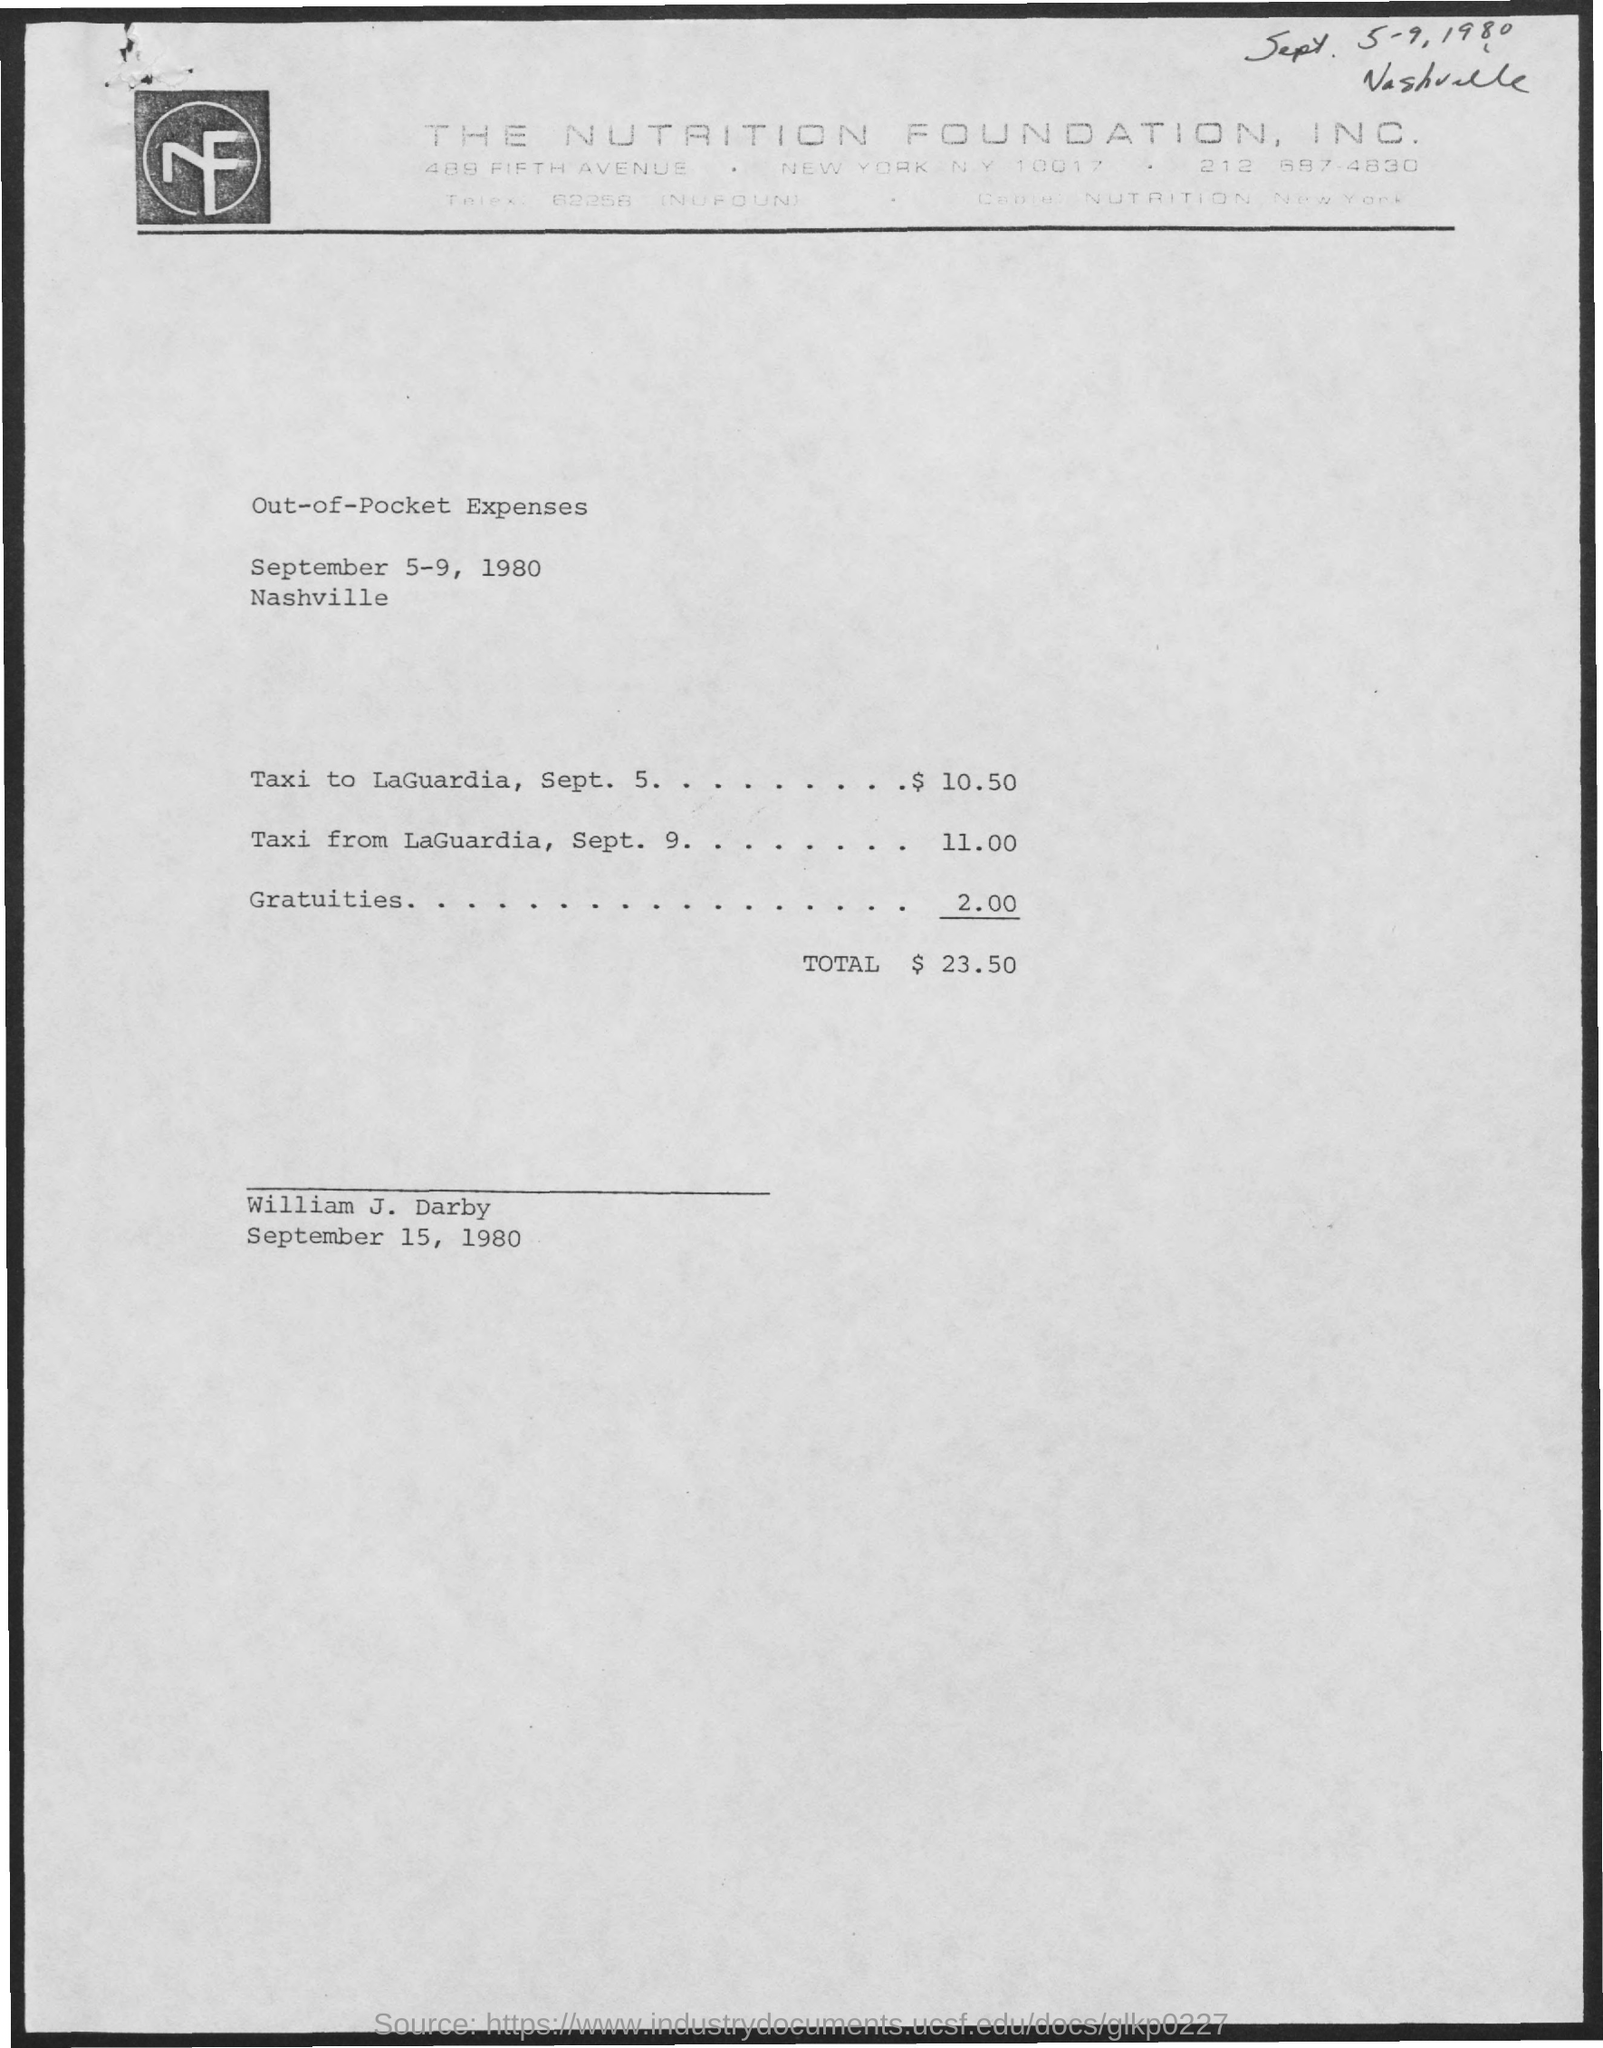What are the dates scheduled for the meeting as mentioned in the given page ?
Your response must be concise. September 5-9, 1980. What are the expenses for taxi to laguardia on sept. 5 ?
Offer a terse response. $ 10.50. What are the expenses for taxi from la guardia on sept. 9 ?
Give a very brief answer. 11.00. What are the expenses for gartuities as mentioned in the given form ?
Ensure brevity in your answer.  2.00. What are the total expenses mentioned in the given page ?
Ensure brevity in your answer.  $ 23.50. 